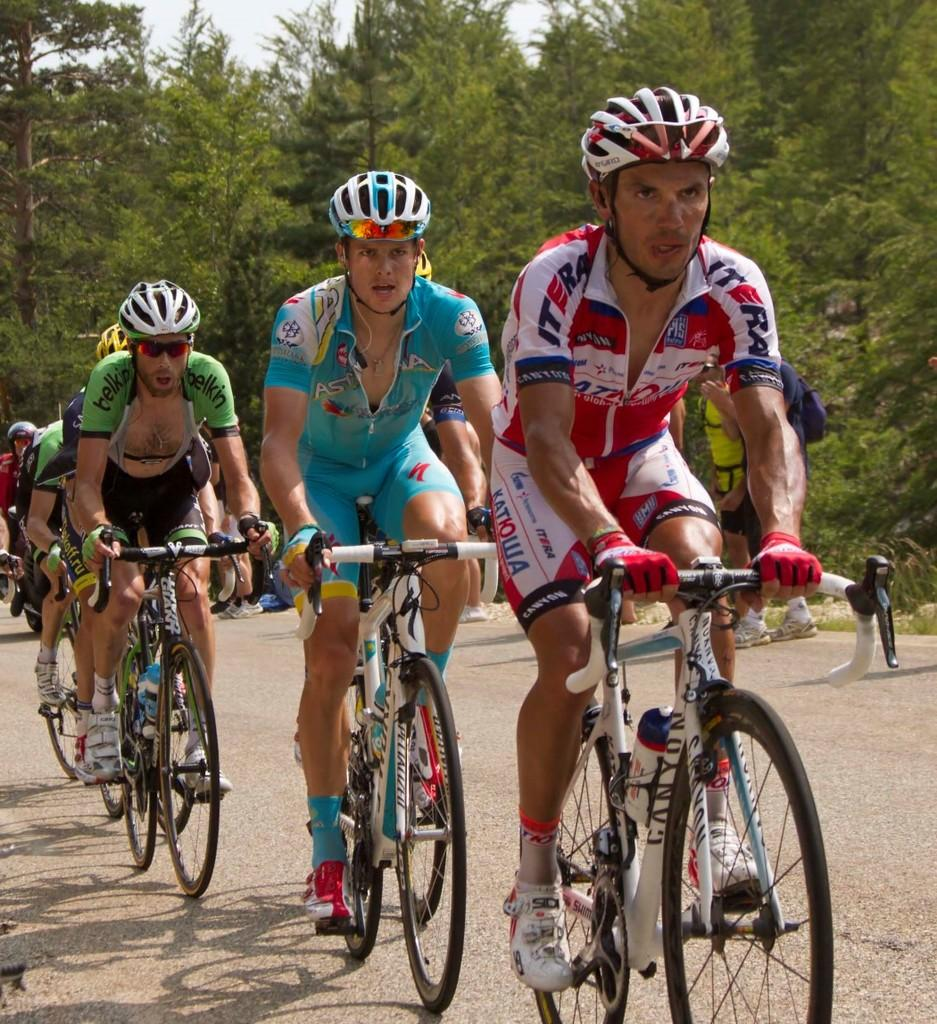What are the persons in the image doing? The persons in the image are riding bicycles. Where are the persons located in the image? The persons are on the road in the image. What type of vegetation can be seen in the image? There are trees visible in the image. What is visible in the background of the image? The sky is visible in the image. How many streetlights are present on the north side of the road in the image? There is no mention of streetlights or a specific direction (north) in the image, so it is not possible to answer that question. 